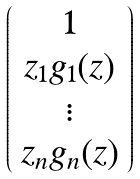Convert formula to latex. <formula><loc_0><loc_0><loc_500><loc_500>\left ( \begin{array} { c } 1 \\ z _ { 1 } g _ { 1 } ( z ) \\ \vdots \\ z _ { n } g _ { n } ( z ) \end{array} \right )</formula> 